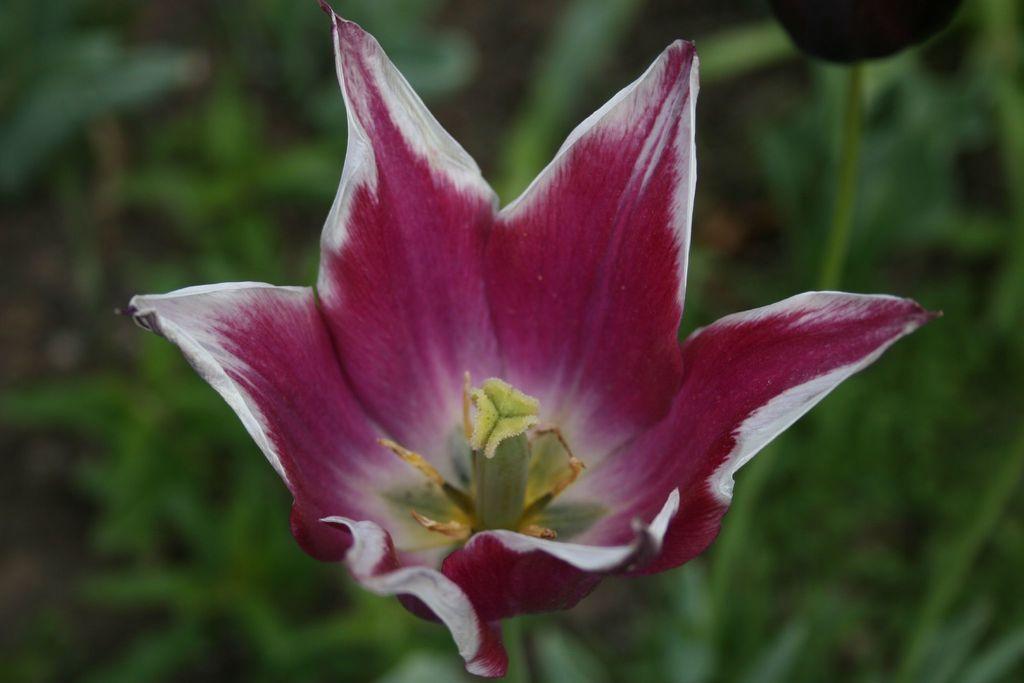Can you describe this image briefly? In the center of the image we can see a flower which is in purple color. At the bottom there are plants. 